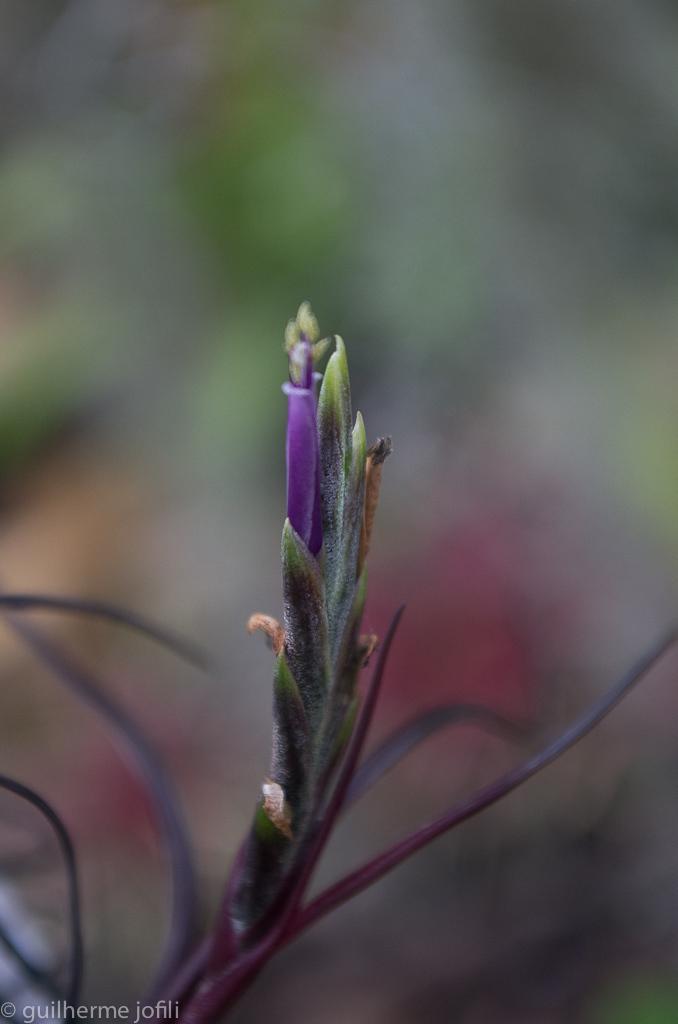How would you summarize this image in a sentence or two? In the foreground of this image, there is a purple flower and few buds. We can also see few leaves and the background image is blur. 